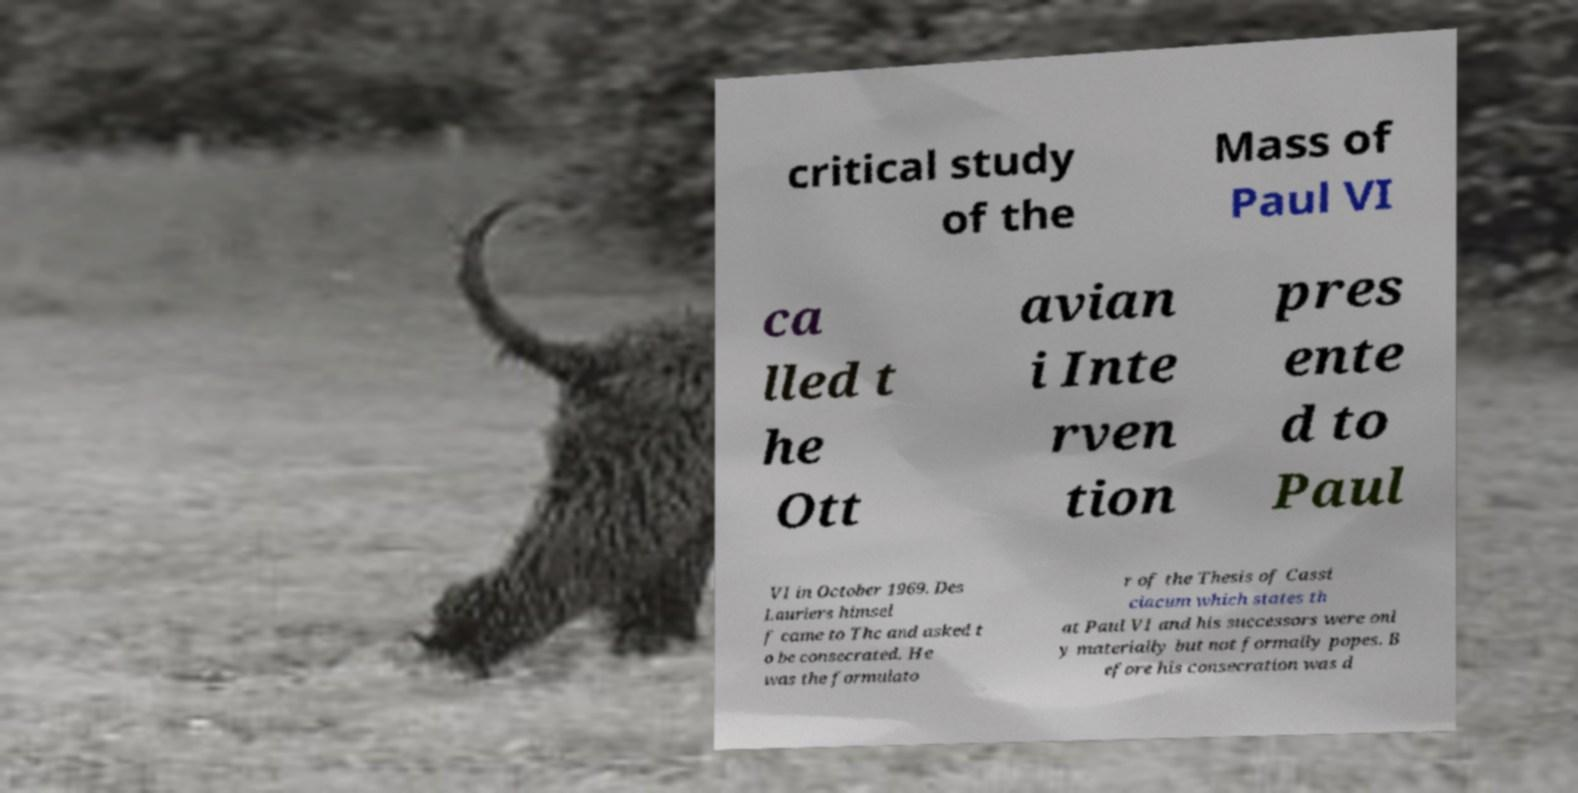Can you read and provide the text displayed in the image?This photo seems to have some interesting text. Can you extract and type it out for me? critical study of the Mass of Paul VI ca lled t he Ott avian i Inte rven tion pres ente d to Paul VI in October 1969. Des Lauriers himsel f came to Thc and asked t o be consecrated. He was the formulato r of the Thesis of Cassi ciacum which states th at Paul VI and his successors were onl y materially but not formally popes. B efore his consecration was d 